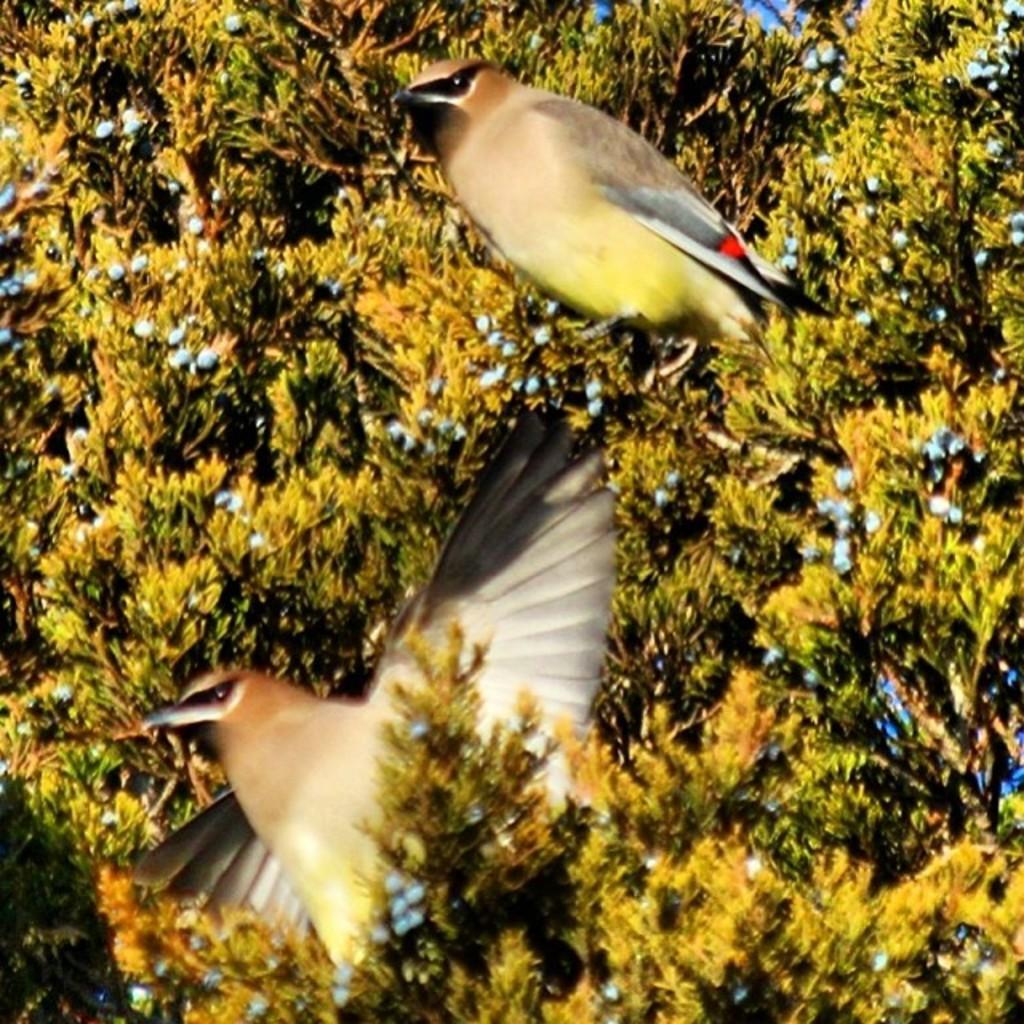Could you give a brief overview of what you see in this image? As we can see in the image there are trees and two birds. 